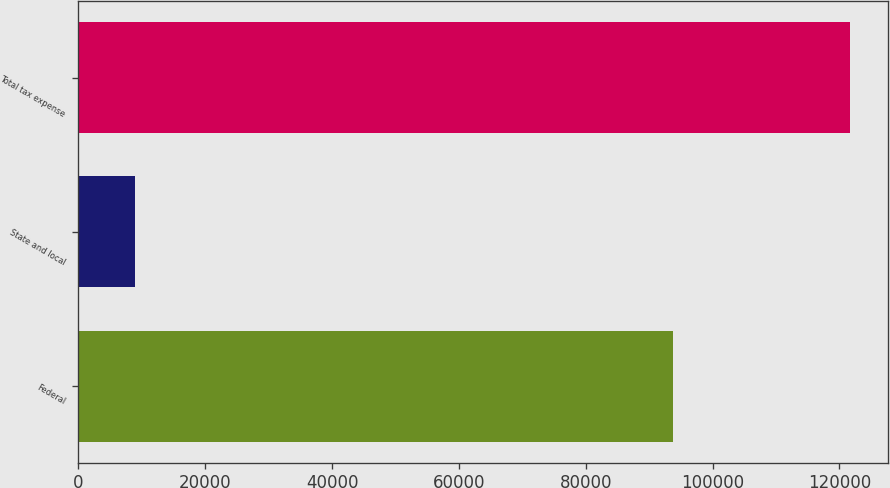Convert chart. <chart><loc_0><loc_0><loc_500><loc_500><bar_chart><fcel>Federal<fcel>State and local<fcel>Total tax expense<nl><fcel>93699<fcel>8985<fcel>121643<nl></chart> 